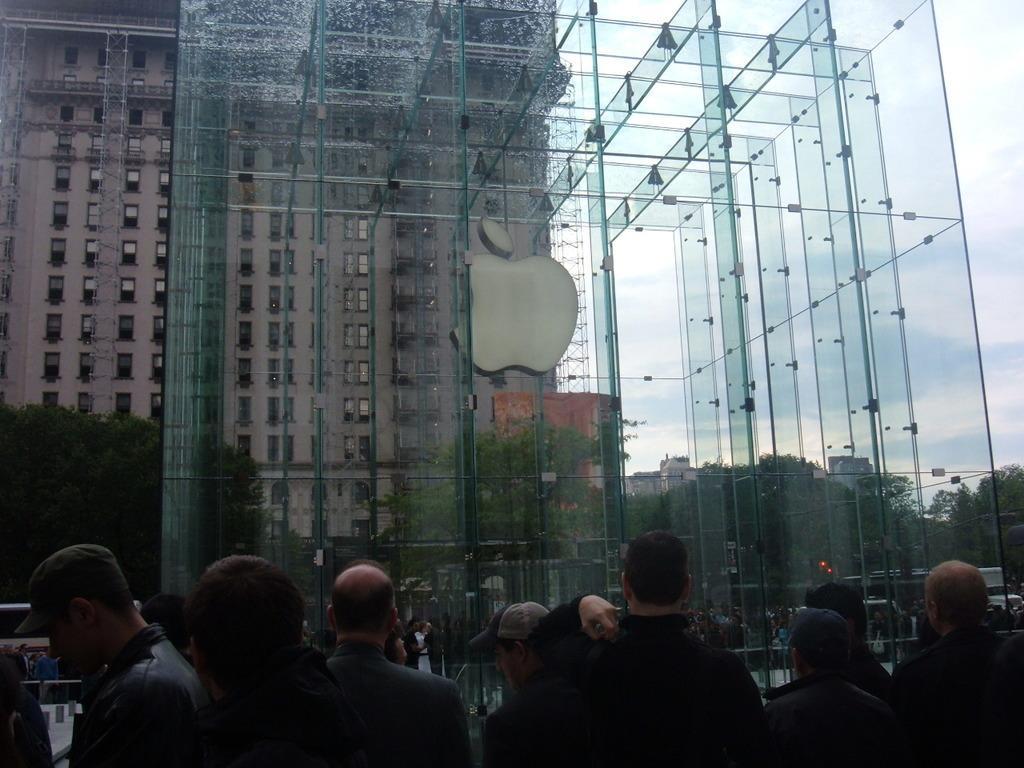Please provide a concise description of this image. In this image we can see buildings, glasses, trees, people standing on the road and sky with clouds. 